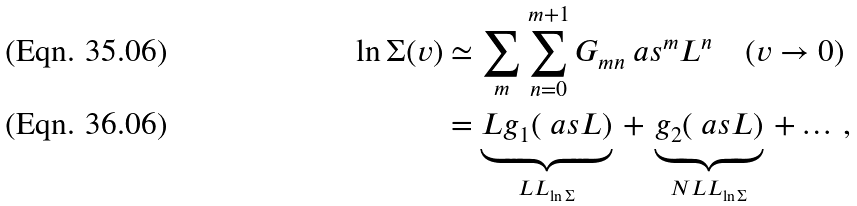Convert formula to latex. <formula><loc_0><loc_0><loc_500><loc_500>\ln \Sigma ( v ) & \simeq \sum _ { m } \sum _ { n = 0 } ^ { m + 1 } G _ { m n } \ a s ^ { m } L ^ { n } \quad ( v \to 0 ) \\ & = \underbrace { L g _ { 1 } ( \ a s L ) } _ { L L _ { \ln \Sigma } } \, + \, \underbrace { g _ { 2 } ( \ a s L ) } _ { N L L _ { \ln \Sigma } } \, + \dots \, ,</formula> 